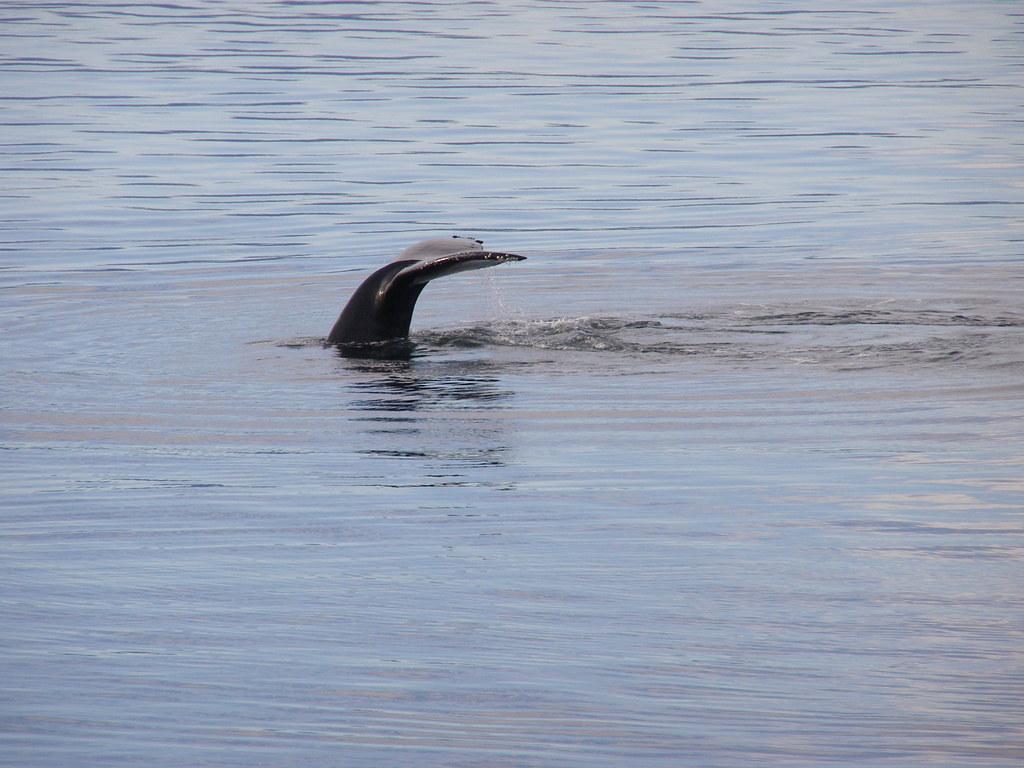How would you summarize this image in a sentence or two? In this image I can see an aquatic animal in the water. I can see the water in blue color. 